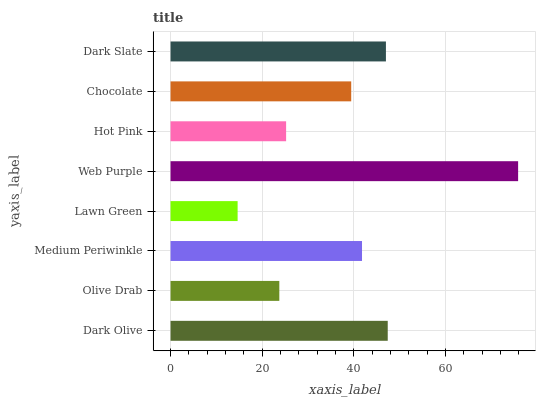Is Lawn Green the minimum?
Answer yes or no. Yes. Is Web Purple the maximum?
Answer yes or no. Yes. Is Olive Drab the minimum?
Answer yes or no. No. Is Olive Drab the maximum?
Answer yes or no. No. Is Dark Olive greater than Olive Drab?
Answer yes or no. Yes. Is Olive Drab less than Dark Olive?
Answer yes or no. Yes. Is Olive Drab greater than Dark Olive?
Answer yes or no. No. Is Dark Olive less than Olive Drab?
Answer yes or no. No. Is Medium Periwinkle the high median?
Answer yes or no. Yes. Is Chocolate the low median?
Answer yes or no. Yes. Is Lawn Green the high median?
Answer yes or no. No. Is Dark Olive the low median?
Answer yes or no. No. 